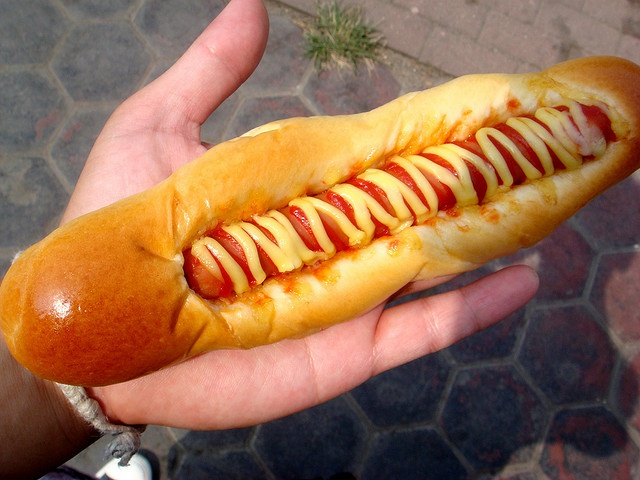Describe the objects in this image and their specific colors. I can see people in gray, lightpink, brown, salmon, and maroon tones and hot dog in gray, brown, gold, tan, and khaki tones in this image. 